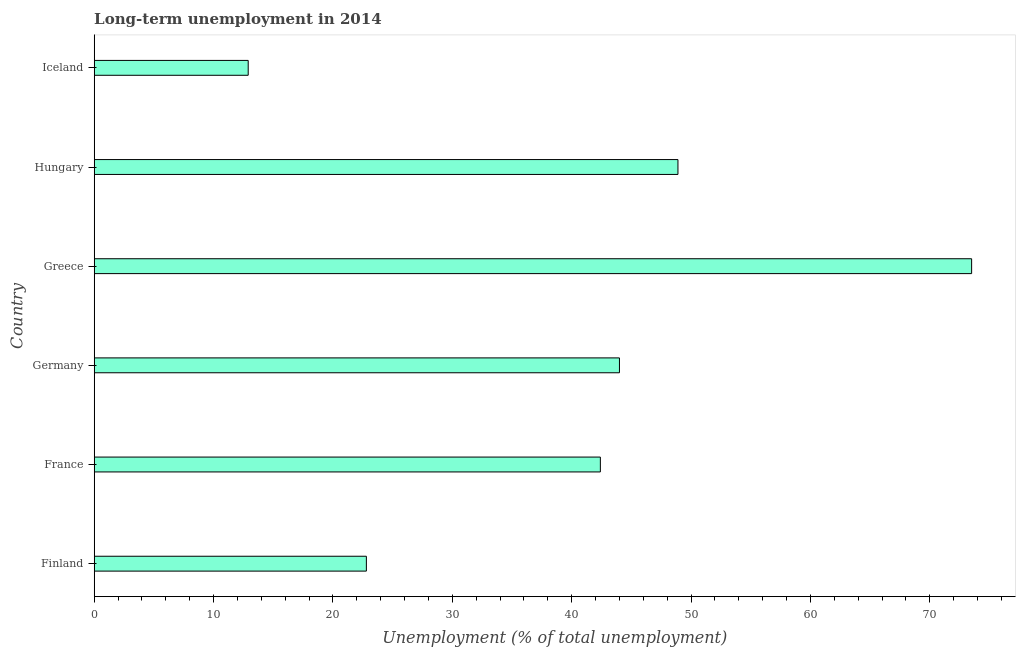Does the graph contain any zero values?
Offer a very short reply. No. Does the graph contain grids?
Your response must be concise. No. What is the title of the graph?
Provide a succinct answer. Long-term unemployment in 2014. What is the label or title of the X-axis?
Your answer should be compact. Unemployment (% of total unemployment). What is the label or title of the Y-axis?
Give a very brief answer. Country. What is the long-term unemployment in Iceland?
Offer a very short reply. 12.9. Across all countries, what is the maximum long-term unemployment?
Give a very brief answer. 73.5. Across all countries, what is the minimum long-term unemployment?
Your answer should be very brief. 12.9. In which country was the long-term unemployment maximum?
Your answer should be very brief. Greece. In which country was the long-term unemployment minimum?
Give a very brief answer. Iceland. What is the sum of the long-term unemployment?
Keep it short and to the point. 244.5. What is the difference between the long-term unemployment in Finland and Hungary?
Provide a succinct answer. -26.1. What is the average long-term unemployment per country?
Your response must be concise. 40.75. What is the median long-term unemployment?
Provide a succinct answer. 43.2. What is the ratio of the long-term unemployment in Greece to that in Iceland?
Your response must be concise. 5.7. Is the long-term unemployment in Finland less than that in Hungary?
Make the answer very short. Yes. Is the difference between the long-term unemployment in Finland and France greater than the difference between any two countries?
Ensure brevity in your answer.  No. What is the difference between the highest and the second highest long-term unemployment?
Provide a short and direct response. 24.6. Is the sum of the long-term unemployment in France and Greece greater than the maximum long-term unemployment across all countries?
Keep it short and to the point. Yes. What is the difference between the highest and the lowest long-term unemployment?
Your answer should be very brief. 60.6. How many bars are there?
Keep it short and to the point. 6. What is the difference between two consecutive major ticks on the X-axis?
Provide a succinct answer. 10. Are the values on the major ticks of X-axis written in scientific E-notation?
Your response must be concise. No. What is the Unemployment (% of total unemployment) of Finland?
Your response must be concise. 22.8. What is the Unemployment (% of total unemployment) in France?
Your answer should be very brief. 42.4. What is the Unemployment (% of total unemployment) of Germany?
Offer a terse response. 44. What is the Unemployment (% of total unemployment) of Greece?
Ensure brevity in your answer.  73.5. What is the Unemployment (% of total unemployment) of Hungary?
Provide a short and direct response. 48.9. What is the Unemployment (% of total unemployment) in Iceland?
Offer a very short reply. 12.9. What is the difference between the Unemployment (% of total unemployment) in Finland and France?
Ensure brevity in your answer.  -19.6. What is the difference between the Unemployment (% of total unemployment) in Finland and Germany?
Provide a succinct answer. -21.2. What is the difference between the Unemployment (% of total unemployment) in Finland and Greece?
Make the answer very short. -50.7. What is the difference between the Unemployment (% of total unemployment) in Finland and Hungary?
Provide a short and direct response. -26.1. What is the difference between the Unemployment (% of total unemployment) in Finland and Iceland?
Offer a terse response. 9.9. What is the difference between the Unemployment (% of total unemployment) in France and Germany?
Your answer should be very brief. -1.6. What is the difference between the Unemployment (% of total unemployment) in France and Greece?
Your answer should be compact. -31.1. What is the difference between the Unemployment (% of total unemployment) in France and Iceland?
Offer a very short reply. 29.5. What is the difference between the Unemployment (% of total unemployment) in Germany and Greece?
Offer a very short reply. -29.5. What is the difference between the Unemployment (% of total unemployment) in Germany and Iceland?
Provide a short and direct response. 31.1. What is the difference between the Unemployment (% of total unemployment) in Greece and Hungary?
Give a very brief answer. 24.6. What is the difference between the Unemployment (% of total unemployment) in Greece and Iceland?
Provide a succinct answer. 60.6. What is the difference between the Unemployment (% of total unemployment) in Hungary and Iceland?
Provide a succinct answer. 36. What is the ratio of the Unemployment (% of total unemployment) in Finland to that in France?
Offer a very short reply. 0.54. What is the ratio of the Unemployment (% of total unemployment) in Finland to that in Germany?
Provide a short and direct response. 0.52. What is the ratio of the Unemployment (% of total unemployment) in Finland to that in Greece?
Offer a very short reply. 0.31. What is the ratio of the Unemployment (% of total unemployment) in Finland to that in Hungary?
Provide a succinct answer. 0.47. What is the ratio of the Unemployment (% of total unemployment) in Finland to that in Iceland?
Offer a very short reply. 1.77. What is the ratio of the Unemployment (% of total unemployment) in France to that in Greece?
Your response must be concise. 0.58. What is the ratio of the Unemployment (% of total unemployment) in France to that in Hungary?
Provide a short and direct response. 0.87. What is the ratio of the Unemployment (% of total unemployment) in France to that in Iceland?
Your answer should be very brief. 3.29. What is the ratio of the Unemployment (% of total unemployment) in Germany to that in Greece?
Your answer should be compact. 0.6. What is the ratio of the Unemployment (% of total unemployment) in Germany to that in Iceland?
Provide a succinct answer. 3.41. What is the ratio of the Unemployment (% of total unemployment) in Greece to that in Hungary?
Your response must be concise. 1.5. What is the ratio of the Unemployment (% of total unemployment) in Greece to that in Iceland?
Your answer should be compact. 5.7. What is the ratio of the Unemployment (% of total unemployment) in Hungary to that in Iceland?
Keep it short and to the point. 3.79. 